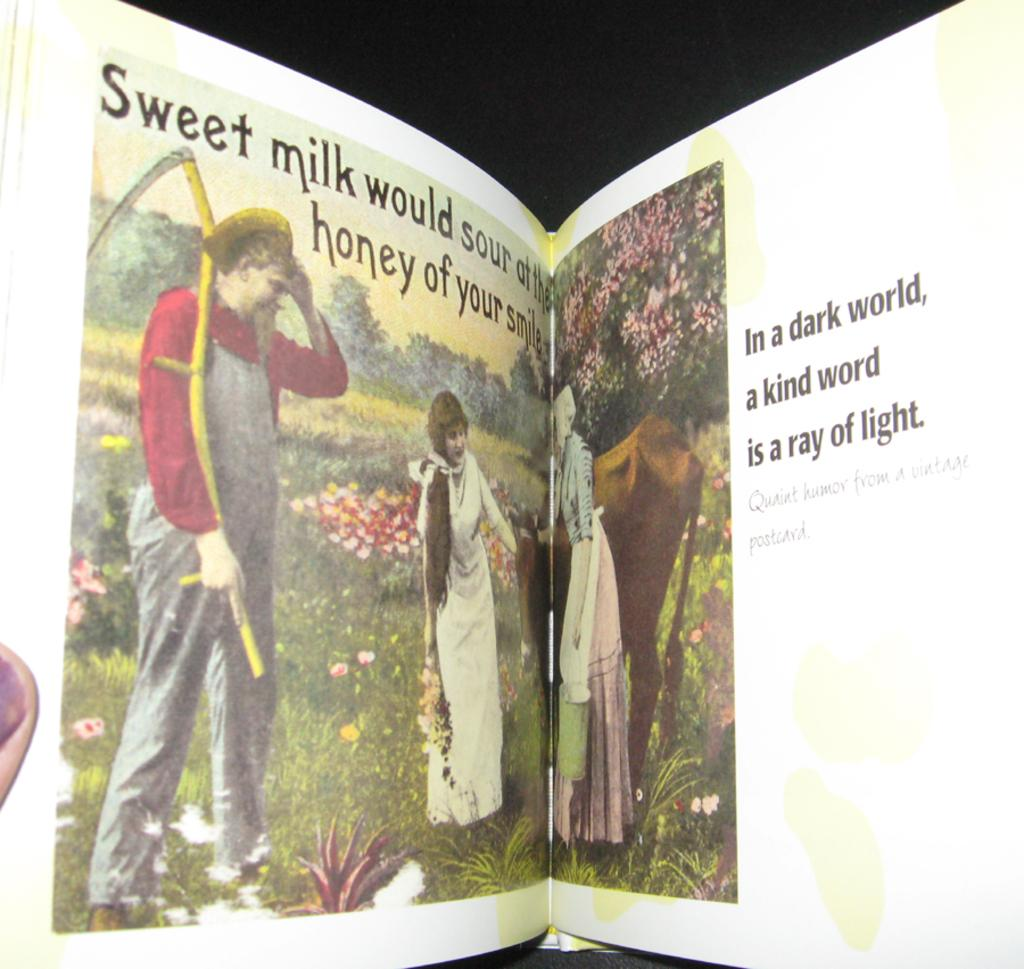<image>
Create a compact narrative representing the image presented. A book is open to a page that shows three people in a meadow and says In a dark world. 